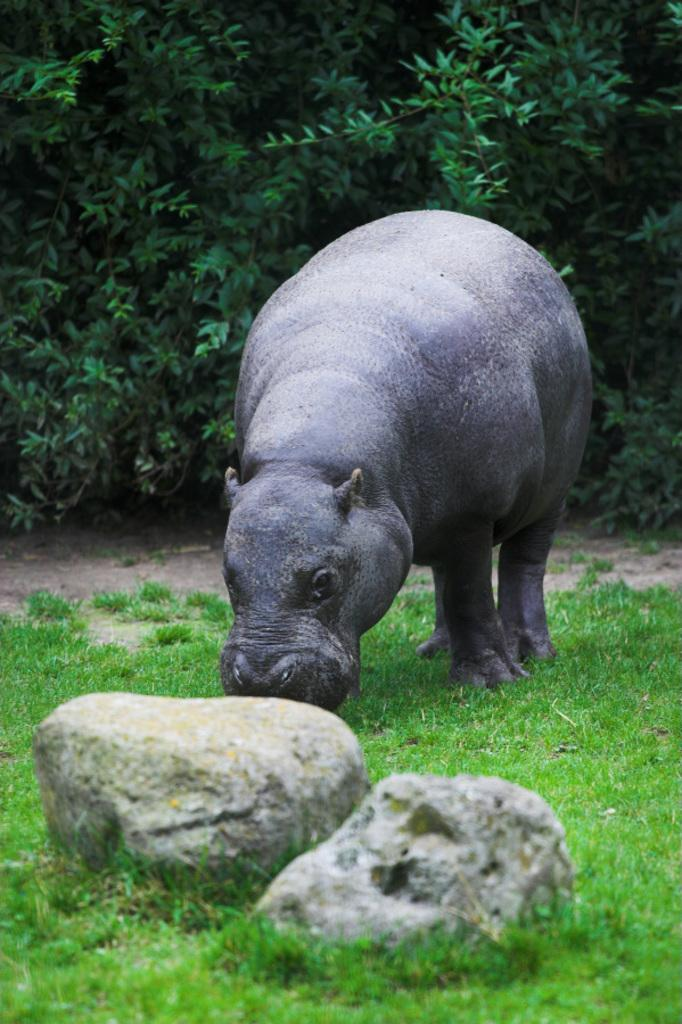What type of creature is in the image? There is an animal in the image. Where is the animal located? The animal is on the ground. What objects are in front of the animal? There are two stones in front of the animal. What can be seen in the background of the image? There are trees in the background of the image. What type of tub is the animal using in the image? There is no tub present in the image; the animal is on the ground with stones in front of it. 